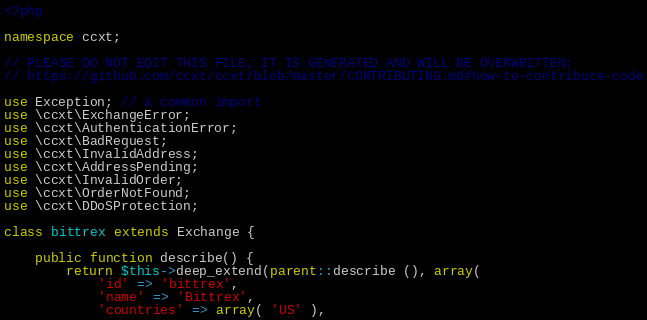<code> <loc_0><loc_0><loc_500><loc_500><_PHP_><?php

namespace ccxt;

// PLEASE DO NOT EDIT THIS FILE, IT IS GENERATED AND WILL BE OVERWRITTEN:
// https://github.com/ccxt/ccxt/blob/master/CONTRIBUTING.md#how-to-contribute-code

use Exception; // a common import
use \ccxt\ExchangeError;
use \ccxt\AuthenticationError;
use \ccxt\BadRequest;
use \ccxt\InvalidAddress;
use \ccxt\AddressPending;
use \ccxt\InvalidOrder;
use \ccxt\OrderNotFound;
use \ccxt\DDoSProtection;

class bittrex extends Exchange {

    public function describe() {
        return $this->deep_extend(parent::describe (), array(
            'id' => 'bittrex',
            'name' => 'Bittrex',
            'countries' => array( 'US' ),</code> 